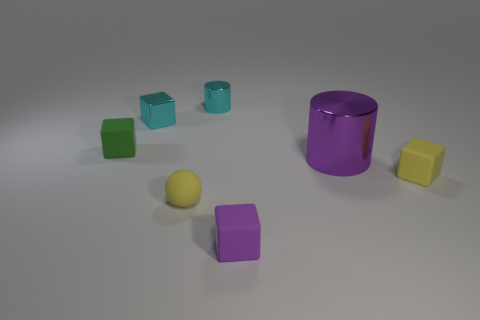Subtract 1 cubes. How many cubes are left? 3 Add 2 yellow matte spheres. How many objects exist? 9 Subtract all cubes. How many objects are left? 3 Add 3 large brown rubber things. How many large brown rubber things exist? 3 Subtract 1 yellow spheres. How many objects are left? 6 Subtract all red matte spheres. Subtract all spheres. How many objects are left? 6 Add 5 small yellow rubber cubes. How many small yellow rubber cubes are left? 6 